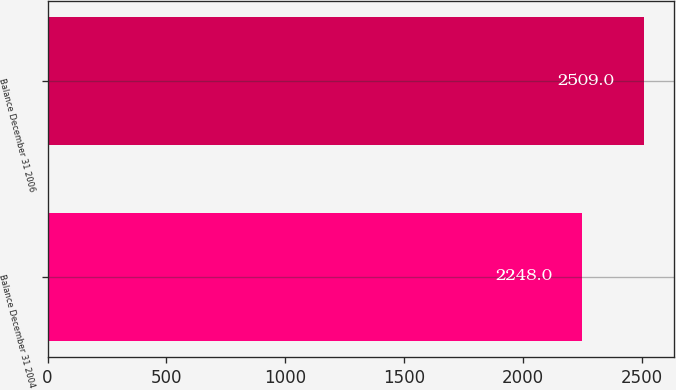Convert chart. <chart><loc_0><loc_0><loc_500><loc_500><bar_chart><fcel>Balance December 31 2004<fcel>Balance December 31 2006<nl><fcel>2248<fcel>2509<nl></chart> 